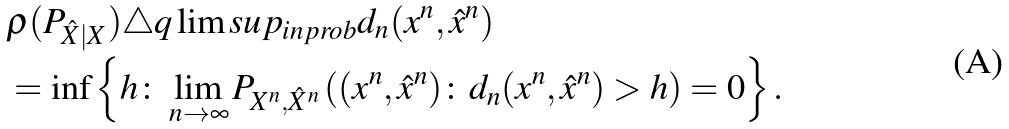<formula> <loc_0><loc_0><loc_500><loc_500>& \rho ( P _ { \hat { X } | X } ) \triangle q \lim s u p _ { i n p r o b } d _ { n } ( x ^ { n } , \hat { x } ^ { n } ) \\ & = \inf \left \{ h \colon \lim _ { n \to \infty } P _ { X ^ { n } , \hat { X } ^ { n } } \left ( ( x ^ { n } , \hat { x } ^ { n } ) \colon d _ { n } ( x ^ { n } , \hat { x } ^ { n } ) > h \right ) = 0 \right \} .</formula> 